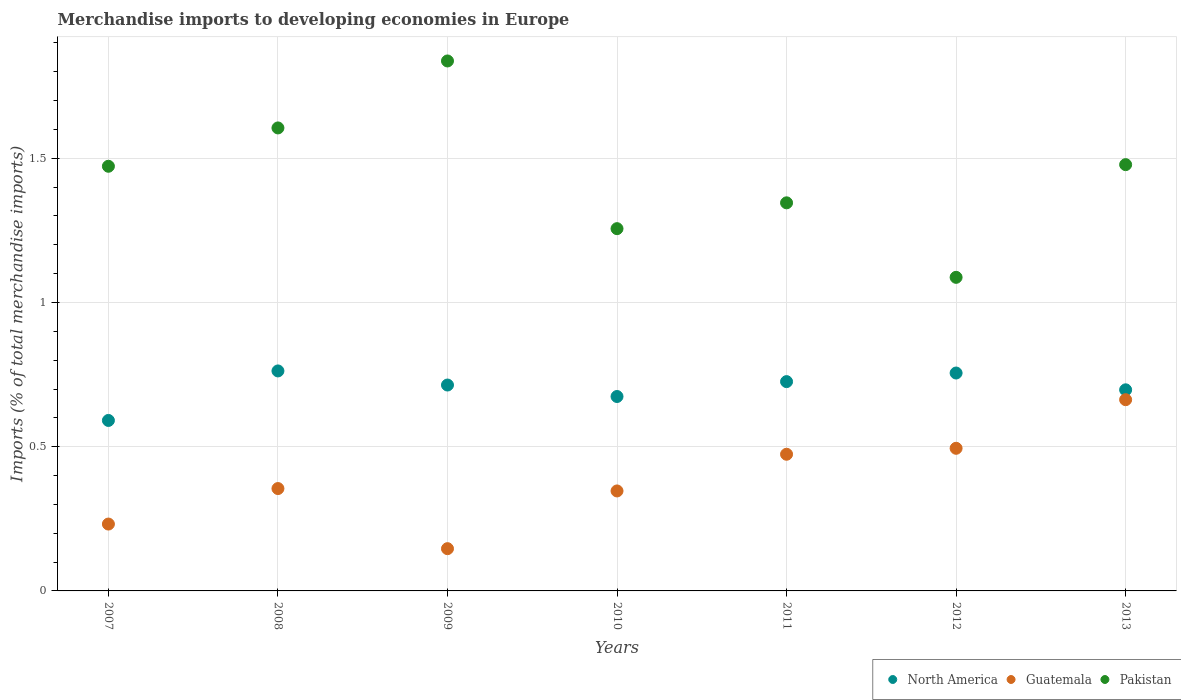How many different coloured dotlines are there?
Make the answer very short. 3. What is the percentage total merchandise imports in North America in 2007?
Your answer should be very brief. 0.59. Across all years, what is the maximum percentage total merchandise imports in North America?
Your answer should be very brief. 0.76. Across all years, what is the minimum percentage total merchandise imports in Guatemala?
Offer a very short reply. 0.15. What is the total percentage total merchandise imports in North America in the graph?
Your answer should be very brief. 4.92. What is the difference between the percentage total merchandise imports in North America in 2007 and that in 2008?
Ensure brevity in your answer.  -0.17. What is the difference between the percentage total merchandise imports in Guatemala in 2010 and the percentage total merchandise imports in Pakistan in 2008?
Keep it short and to the point. -1.26. What is the average percentage total merchandise imports in Guatemala per year?
Keep it short and to the point. 0.39. In the year 2012, what is the difference between the percentage total merchandise imports in Guatemala and percentage total merchandise imports in North America?
Your response must be concise. -0.26. In how many years, is the percentage total merchandise imports in North America greater than 0.30000000000000004 %?
Keep it short and to the point. 7. What is the ratio of the percentage total merchandise imports in Guatemala in 2008 to that in 2012?
Keep it short and to the point. 0.72. Is the difference between the percentage total merchandise imports in Guatemala in 2009 and 2013 greater than the difference between the percentage total merchandise imports in North America in 2009 and 2013?
Your answer should be compact. No. What is the difference between the highest and the second highest percentage total merchandise imports in Pakistan?
Provide a short and direct response. 0.23. What is the difference between the highest and the lowest percentage total merchandise imports in North America?
Offer a terse response. 0.17. In how many years, is the percentage total merchandise imports in North America greater than the average percentage total merchandise imports in North America taken over all years?
Make the answer very short. 4. Is the percentage total merchandise imports in Pakistan strictly less than the percentage total merchandise imports in Guatemala over the years?
Provide a succinct answer. No. Does the graph contain any zero values?
Your answer should be very brief. No. How many legend labels are there?
Keep it short and to the point. 3. What is the title of the graph?
Offer a very short reply. Merchandise imports to developing economies in Europe. What is the label or title of the Y-axis?
Offer a very short reply. Imports (% of total merchandise imports). What is the Imports (% of total merchandise imports) in North America in 2007?
Make the answer very short. 0.59. What is the Imports (% of total merchandise imports) of Guatemala in 2007?
Ensure brevity in your answer.  0.23. What is the Imports (% of total merchandise imports) of Pakistan in 2007?
Offer a terse response. 1.47. What is the Imports (% of total merchandise imports) of North America in 2008?
Offer a terse response. 0.76. What is the Imports (% of total merchandise imports) of Guatemala in 2008?
Provide a short and direct response. 0.35. What is the Imports (% of total merchandise imports) in Pakistan in 2008?
Offer a terse response. 1.61. What is the Imports (% of total merchandise imports) of North America in 2009?
Provide a succinct answer. 0.71. What is the Imports (% of total merchandise imports) in Guatemala in 2009?
Your answer should be very brief. 0.15. What is the Imports (% of total merchandise imports) of Pakistan in 2009?
Offer a very short reply. 1.84. What is the Imports (% of total merchandise imports) in North America in 2010?
Provide a short and direct response. 0.67. What is the Imports (% of total merchandise imports) of Guatemala in 2010?
Your answer should be very brief. 0.35. What is the Imports (% of total merchandise imports) of Pakistan in 2010?
Make the answer very short. 1.26. What is the Imports (% of total merchandise imports) of North America in 2011?
Your answer should be compact. 0.73. What is the Imports (% of total merchandise imports) of Guatemala in 2011?
Give a very brief answer. 0.47. What is the Imports (% of total merchandise imports) in Pakistan in 2011?
Make the answer very short. 1.35. What is the Imports (% of total merchandise imports) of North America in 2012?
Keep it short and to the point. 0.76. What is the Imports (% of total merchandise imports) of Guatemala in 2012?
Offer a very short reply. 0.49. What is the Imports (% of total merchandise imports) in Pakistan in 2012?
Your response must be concise. 1.09. What is the Imports (% of total merchandise imports) of North America in 2013?
Offer a very short reply. 0.7. What is the Imports (% of total merchandise imports) of Guatemala in 2013?
Your response must be concise. 0.66. What is the Imports (% of total merchandise imports) in Pakistan in 2013?
Ensure brevity in your answer.  1.48. Across all years, what is the maximum Imports (% of total merchandise imports) in North America?
Ensure brevity in your answer.  0.76. Across all years, what is the maximum Imports (% of total merchandise imports) of Guatemala?
Your answer should be compact. 0.66. Across all years, what is the maximum Imports (% of total merchandise imports) of Pakistan?
Offer a terse response. 1.84. Across all years, what is the minimum Imports (% of total merchandise imports) in North America?
Provide a short and direct response. 0.59. Across all years, what is the minimum Imports (% of total merchandise imports) in Guatemala?
Make the answer very short. 0.15. Across all years, what is the minimum Imports (% of total merchandise imports) of Pakistan?
Give a very brief answer. 1.09. What is the total Imports (% of total merchandise imports) of North America in the graph?
Offer a terse response. 4.92. What is the total Imports (% of total merchandise imports) of Guatemala in the graph?
Offer a very short reply. 2.71. What is the total Imports (% of total merchandise imports) in Pakistan in the graph?
Offer a terse response. 10.08. What is the difference between the Imports (% of total merchandise imports) in North America in 2007 and that in 2008?
Ensure brevity in your answer.  -0.17. What is the difference between the Imports (% of total merchandise imports) in Guatemala in 2007 and that in 2008?
Make the answer very short. -0.12. What is the difference between the Imports (% of total merchandise imports) in Pakistan in 2007 and that in 2008?
Make the answer very short. -0.13. What is the difference between the Imports (% of total merchandise imports) in North America in 2007 and that in 2009?
Your answer should be very brief. -0.12. What is the difference between the Imports (% of total merchandise imports) of Guatemala in 2007 and that in 2009?
Ensure brevity in your answer.  0.09. What is the difference between the Imports (% of total merchandise imports) of Pakistan in 2007 and that in 2009?
Provide a succinct answer. -0.37. What is the difference between the Imports (% of total merchandise imports) of North America in 2007 and that in 2010?
Provide a short and direct response. -0.08. What is the difference between the Imports (% of total merchandise imports) of Guatemala in 2007 and that in 2010?
Provide a short and direct response. -0.11. What is the difference between the Imports (% of total merchandise imports) of Pakistan in 2007 and that in 2010?
Your response must be concise. 0.22. What is the difference between the Imports (% of total merchandise imports) of North America in 2007 and that in 2011?
Offer a very short reply. -0.13. What is the difference between the Imports (% of total merchandise imports) in Guatemala in 2007 and that in 2011?
Keep it short and to the point. -0.24. What is the difference between the Imports (% of total merchandise imports) in Pakistan in 2007 and that in 2011?
Your answer should be compact. 0.13. What is the difference between the Imports (% of total merchandise imports) of North America in 2007 and that in 2012?
Give a very brief answer. -0.16. What is the difference between the Imports (% of total merchandise imports) of Guatemala in 2007 and that in 2012?
Offer a very short reply. -0.26. What is the difference between the Imports (% of total merchandise imports) in Pakistan in 2007 and that in 2012?
Ensure brevity in your answer.  0.39. What is the difference between the Imports (% of total merchandise imports) in North America in 2007 and that in 2013?
Provide a short and direct response. -0.11. What is the difference between the Imports (% of total merchandise imports) in Guatemala in 2007 and that in 2013?
Ensure brevity in your answer.  -0.43. What is the difference between the Imports (% of total merchandise imports) in Pakistan in 2007 and that in 2013?
Make the answer very short. -0.01. What is the difference between the Imports (% of total merchandise imports) in North America in 2008 and that in 2009?
Give a very brief answer. 0.05. What is the difference between the Imports (% of total merchandise imports) in Guatemala in 2008 and that in 2009?
Keep it short and to the point. 0.21. What is the difference between the Imports (% of total merchandise imports) in Pakistan in 2008 and that in 2009?
Your answer should be very brief. -0.23. What is the difference between the Imports (% of total merchandise imports) in North America in 2008 and that in 2010?
Your answer should be compact. 0.09. What is the difference between the Imports (% of total merchandise imports) of Guatemala in 2008 and that in 2010?
Offer a very short reply. 0.01. What is the difference between the Imports (% of total merchandise imports) of Pakistan in 2008 and that in 2010?
Your response must be concise. 0.35. What is the difference between the Imports (% of total merchandise imports) of North America in 2008 and that in 2011?
Your answer should be very brief. 0.04. What is the difference between the Imports (% of total merchandise imports) of Guatemala in 2008 and that in 2011?
Give a very brief answer. -0.12. What is the difference between the Imports (% of total merchandise imports) of Pakistan in 2008 and that in 2011?
Provide a short and direct response. 0.26. What is the difference between the Imports (% of total merchandise imports) in North America in 2008 and that in 2012?
Offer a very short reply. 0.01. What is the difference between the Imports (% of total merchandise imports) in Guatemala in 2008 and that in 2012?
Ensure brevity in your answer.  -0.14. What is the difference between the Imports (% of total merchandise imports) of Pakistan in 2008 and that in 2012?
Provide a succinct answer. 0.52. What is the difference between the Imports (% of total merchandise imports) in North America in 2008 and that in 2013?
Offer a terse response. 0.07. What is the difference between the Imports (% of total merchandise imports) of Guatemala in 2008 and that in 2013?
Make the answer very short. -0.31. What is the difference between the Imports (% of total merchandise imports) of Pakistan in 2008 and that in 2013?
Ensure brevity in your answer.  0.13. What is the difference between the Imports (% of total merchandise imports) of North America in 2009 and that in 2010?
Your answer should be very brief. 0.04. What is the difference between the Imports (% of total merchandise imports) in Guatemala in 2009 and that in 2010?
Your response must be concise. -0.2. What is the difference between the Imports (% of total merchandise imports) in Pakistan in 2009 and that in 2010?
Make the answer very short. 0.58. What is the difference between the Imports (% of total merchandise imports) in North America in 2009 and that in 2011?
Ensure brevity in your answer.  -0.01. What is the difference between the Imports (% of total merchandise imports) of Guatemala in 2009 and that in 2011?
Keep it short and to the point. -0.33. What is the difference between the Imports (% of total merchandise imports) in Pakistan in 2009 and that in 2011?
Keep it short and to the point. 0.49. What is the difference between the Imports (% of total merchandise imports) of North America in 2009 and that in 2012?
Give a very brief answer. -0.04. What is the difference between the Imports (% of total merchandise imports) in Guatemala in 2009 and that in 2012?
Your answer should be compact. -0.35. What is the difference between the Imports (% of total merchandise imports) of Pakistan in 2009 and that in 2012?
Your answer should be very brief. 0.75. What is the difference between the Imports (% of total merchandise imports) in North America in 2009 and that in 2013?
Provide a succinct answer. 0.02. What is the difference between the Imports (% of total merchandise imports) of Guatemala in 2009 and that in 2013?
Offer a terse response. -0.52. What is the difference between the Imports (% of total merchandise imports) in Pakistan in 2009 and that in 2013?
Your answer should be very brief. 0.36. What is the difference between the Imports (% of total merchandise imports) of North America in 2010 and that in 2011?
Your response must be concise. -0.05. What is the difference between the Imports (% of total merchandise imports) of Guatemala in 2010 and that in 2011?
Provide a short and direct response. -0.13. What is the difference between the Imports (% of total merchandise imports) of Pakistan in 2010 and that in 2011?
Your answer should be very brief. -0.09. What is the difference between the Imports (% of total merchandise imports) of North America in 2010 and that in 2012?
Make the answer very short. -0.08. What is the difference between the Imports (% of total merchandise imports) in Guatemala in 2010 and that in 2012?
Provide a short and direct response. -0.15. What is the difference between the Imports (% of total merchandise imports) of Pakistan in 2010 and that in 2012?
Offer a very short reply. 0.17. What is the difference between the Imports (% of total merchandise imports) in North America in 2010 and that in 2013?
Your answer should be compact. -0.02. What is the difference between the Imports (% of total merchandise imports) in Guatemala in 2010 and that in 2013?
Provide a short and direct response. -0.32. What is the difference between the Imports (% of total merchandise imports) of Pakistan in 2010 and that in 2013?
Provide a succinct answer. -0.22. What is the difference between the Imports (% of total merchandise imports) of North America in 2011 and that in 2012?
Your answer should be very brief. -0.03. What is the difference between the Imports (% of total merchandise imports) in Guatemala in 2011 and that in 2012?
Offer a very short reply. -0.02. What is the difference between the Imports (% of total merchandise imports) of Pakistan in 2011 and that in 2012?
Your answer should be very brief. 0.26. What is the difference between the Imports (% of total merchandise imports) in North America in 2011 and that in 2013?
Offer a terse response. 0.03. What is the difference between the Imports (% of total merchandise imports) of Guatemala in 2011 and that in 2013?
Your response must be concise. -0.19. What is the difference between the Imports (% of total merchandise imports) of Pakistan in 2011 and that in 2013?
Ensure brevity in your answer.  -0.13. What is the difference between the Imports (% of total merchandise imports) in North America in 2012 and that in 2013?
Offer a terse response. 0.06. What is the difference between the Imports (% of total merchandise imports) in Guatemala in 2012 and that in 2013?
Give a very brief answer. -0.17. What is the difference between the Imports (% of total merchandise imports) in Pakistan in 2012 and that in 2013?
Provide a short and direct response. -0.39. What is the difference between the Imports (% of total merchandise imports) in North America in 2007 and the Imports (% of total merchandise imports) in Guatemala in 2008?
Your answer should be very brief. 0.24. What is the difference between the Imports (% of total merchandise imports) in North America in 2007 and the Imports (% of total merchandise imports) in Pakistan in 2008?
Ensure brevity in your answer.  -1.01. What is the difference between the Imports (% of total merchandise imports) in Guatemala in 2007 and the Imports (% of total merchandise imports) in Pakistan in 2008?
Your response must be concise. -1.37. What is the difference between the Imports (% of total merchandise imports) in North America in 2007 and the Imports (% of total merchandise imports) in Guatemala in 2009?
Offer a terse response. 0.44. What is the difference between the Imports (% of total merchandise imports) in North America in 2007 and the Imports (% of total merchandise imports) in Pakistan in 2009?
Provide a succinct answer. -1.25. What is the difference between the Imports (% of total merchandise imports) in Guatemala in 2007 and the Imports (% of total merchandise imports) in Pakistan in 2009?
Your answer should be very brief. -1.61. What is the difference between the Imports (% of total merchandise imports) in North America in 2007 and the Imports (% of total merchandise imports) in Guatemala in 2010?
Your answer should be compact. 0.24. What is the difference between the Imports (% of total merchandise imports) in North America in 2007 and the Imports (% of total merchandise imports) in Pakistan in 2010?
Your response must be concise. -0.66. What is the difference between the Imports (% of total merchandise imports) in Guatemala in 2007 and the Imports (% of total merchandise imports) in Pakistan in 2010?
Your response must be concise. -1.02. What is the difference between the Imports (% of total merchandise imports) in North America in 2007 and the Imports (% of total merchandise imports) in Guatemala in 2011?
Your answer should be very brief. 0.12. What is the difference between the Imports (% of total merchandise imports) of North America in 2007 and the Imports (% of total merchandise imports) of Pakistan in 2011?
Make the answer very short. -0.75. What is the difference between the Imports (% of total merchandise imports) of Guatemala in 2007 and the Imports (% of total merchandise imports) of Pakistan in 2011?
Keep it short and to the point. -1.11. What is the difference between the Imports (% of total merchandise imports) of North America in 2007 and the Imports (% of total merchandise imports) of Guatemala in 2012?
Provide a succinct answer. 0.1. What is the difference between the Imports (% of total merchandise imports) in North America in 2007 and the Imports (% of total merchandise imports) in Pakistan in 2012?
Provide a short and direct response. -0.5. What is the difference between the Imports (% of total merchandise imports) in Guatemala in 2007 and the Imports (% of total merchandise imports) in Pakistan in 2012?
Your answer should be very brief. -0.86. What is the difference between the Imports (% of total merchandise imports) of North America in 2007 and the Imports (% of total merchandise imports) of Guatemala in 2013?
Offer a very short reply. -0.07. What is the difference between the Imports (% of total merchandise imports) of North America in 2007 and the Imports (% of total merchandise imports) of Pakistan in 2013?
Give a very brief answer. -0.89. What is the difference between the Imports (% of total merchandise imports) of Guatemala in 2007 and the Imports (% of total merchandise imports) of Pakistan in 2013?
Your answer should be very brief. -1.25. What is the difference between the Imports (% of total merchandise imports) in North America in 2008 and the Imports (% of total merchandise imports) in Guatemala in 2009?
Provide a succinct answer. 0.62. What is the difference between the Imports (% of total merchandise imports) of North America in 2008 and the Imports (% of total merchandise imports) of Pakistan in 2009?
Ensure brevity in your answer.  -1.07. What is the difference between the Imports (% of total merchandise imports) in Guatemala in 2008 and the Imports (% of total merchandise imports) in Pakistan in 2009?
Your answer should be very brief. -1.48. What is the difference between the Imports (% of total merchandise imports) in North America in 2008 and the Imports (% of total merchandise imports) in Guatemala in 2010?
Offer a very short reply. 0.42. What is the difference between the Imports (% of total merchandise imports) in North America in 2008 and the Imports (% of total merchandise imports) in Pakistan in 2010?
Ensure brevity in your answer.  -0.49. What is the difference between the Imports (% of total merchandise imports) in Guatemala in 2008 and the Imports (% of total merchandise imports) in Pakistan in 2010?
Your answer should be compact. -0.9. What is the difference between the Imports (% of total merchandise imports) in North America in 2008 and the Imports (% of total merchandise imports) in Guatemala in 2011?
Your response must be concise. 0.29. What is the difference between the Imports (% of total merchandise imports) of North America in 2008 and the Imports (% of total merchandise imports) of Pakistan in 2011?
Offer a very short reply. -0.58. What is the difference between the Imports (% of total merchandise imports) of Guatemala in 2008 and the Imports (% of total merchandise imports) of Pakistan in 2011?
Offer a very short reply. -0.99. What is the difference between the Imports (% of total merchandise imports) in North America in 2008 and the Imports (% of total merchandise imports) in Guatemala in 2012?
Provide a short and direct response. 0.27. What is the difference between the Imports (% of total merchandise imports) in North America in 2008 and the Imports (% of total merchandise imports) in Pakistan in 2012?
Provide a succinct answer. -0.32. What is the difference between the Imports (% of total merchandise imports) in Guatemala in 2008 and the Imports (% of total merchandise imports) in Pakistan in 2012?
Your response must be concise. -0.73. What is the difference between the Imports (% of total merchandise imports) in North America in 2008 and the Imports (% of total merchandise imports) in Guatemala in 2013?
Your answer should be compact. 0.1. What is the difference between the Imports (% of total merchandise imports) of North America in 2008 and the Imports (% of total merchandise imports) of Pakistan in 2013?
Give a very brief answer. -0.72. What is the difference between the Imports (% of total merchandise imports) in Guatemala in 2008 and the Imports (% of total merchandise imports) in Pakistan in 2013?
Provide a succinct answer. -1.12. What is the difference between the Imports (% of total merchandise imports) of North America in 2009 and the Imports (% of total merchandise imports) of Guatemala in 2010?
Offer a terse response. 0.37. What is the difference between the Imports (% of total merchandise imports) of North America in 2009 and the Imports (% of total merchandise imports) of Pakistan in 2010?
Ensure brevity in your answer.  -0.54. What is the difference between the Imports (% of total merchandise imports) of Guatemala in 2009 and the Imports (% of total merchandise imports) of Pakistan in 2010?
Your answer should be very brief. -1.11. What is the difference between the Imports (% of total merchandise imports) in North America in 2009 and the Imports (% of total merchandise imports) in Guatemala in 2011?
Offer a terse response. 0.24. What is the difference between the Imports (% of total merchandise imports) in North America in 2009 and the Imports (% of total merchandise imports) in Pakistan in 2011?
Provide a succinct answer. -0.63. What is the difference between the Imports (% of total merchandise imports) in Guatemala in 2009 and the Imports (% of total merchandise imports) in Pakistan in 2011?
Provide a succinct answer. -1.2. What is the difference between the Imports (% of total merchandise imports) in North America in 2009 and the Imports (% of total merchandise imports) in Guatemala in 2012?
Keep it short and to the point. 0.22. What is the difference between the Imports (% of total merchandise imports) in North America in 2009 and the Imports (% of total merchandise imports) in Pakistan in 2012?
Offer a terse response. -0.37. What is the difference between the Imports (% of total merchandise imports) of Guatemala in 2009 and the Imports (% of total merchandise imports) of Pakistan in 2012?
Offer a terse response. -0.94. What is the difference between the Imports (% of total merchandise imports) in North America in 2009 and the Imports (% of total merchandise imports) in Guatemala in 2013?
Ensure brevity in your answer.  0.05. What is the difference between the Imports (% of total merchandise imports) in North America in 2009 and the Imports (% of total merchandise imports) in Pakistan in 2013?
Offer a very short reply. -0.76. What is the difference between the Imports (% of total merchandise imports) of Guatemala in 2009 and the Imports (% of total merchandise imports) of Pakistan in 2013?
Keep it short and to the point. -1.33. What is the difference between the Imports (% of total merchandise imports) of North America in 2010 and the Imports (% of total merchandise imports) of Guatemala in 2011?
Your response must be concise. 0.2. What is the difference between the Imports (% of total merchandise imports) in North America in 2010 and the Imports (% of total merchandise imports) in Pakistan in 2011?
Offer a terse response. -0.67. What is the difference between the Imports (% of total merchandise imports) of Guatemala in 2010 and the Imports (% of total merchandise imports) of Pakistan in 2011?
Your answer should be very brief. -1. What is the difference between the Imports (% of total merchandise imports) of North America in 2010 and the Imports (% of total merchandise imports) of Guatemala in 2012?
Ensure brevity in your answer.  0.18. What is the difference between the Imports (% of total merchandise imports) of North America in 2010 and the Imports (% of total merchandise imports) of Pakistan in 2012?
Offer a terse response. -0.41. What is the difference between the Imports (% of total merchandise imports) in Guatemala in 2010 and the Imports (% of total merchandise imports) in Pakistan in 2012?
Ensure brevity in your answer.  -0.74. What is the difference between the Imports (% of total merchandise imports) in North America in 2010 and the Imports (% of total merchandise imports) in Guatemala in 2013?
Ensure brevity in your answer.  0.01. What is the difference between the Imports (% of total merchandise imports) in North America in 2010 and the Imports (% of total merchandise imports) in Pakistan in 2013?
Your answer should be very brief. -0.8. What is the difference between the Imports (% of total merchandise imports) in Guatemala in 2010 and the Imports (% of total merchandise imports) in Pakistan in 2013?
Make the answer very short. -1.13. What is the difference between the Imports (% of total merchandise imports) of North America in 2011 and the Imports (% of total merchandise imports) of Guatemala in 2012?
Your response must be concise. 0.23. What is the difference between the Imports (% of total merchandise imports) of North America in 2011 and the Imports (% of total merchandise imports) of Pakistan in 2012?
Offer a very short reply. -0.36. What is the difference between the Imports (% of total merchandise imports) of Guatemala in 2011 and the Imports (% of total merchandise imports) of Pakistan in 2012?
Make the answer very short. -0.61. What is the difference between the Imports (% of total merchandise imports) of North America in 2011 and the Imports (% of total merchandise imports) of Guatemala in 2013?
Your answer should be very brief. 0.06. What is the difference between the Imports (% of total merchandise imports) in North America in 2011 and the Imports (% of total merchandise imports) in Pakistan in 2013?
Offer a terse response. -0.75. What is the difference between the Imports (% of total merchandise imports) of Guatemala in 2011 and the Imports (% of total merchandise imports) of Pakistan in 2013?
Provide a succinct answer. -1. What is the difference between the Imports (% of total merchandise imports) in North America in 2012 and the Imports (% of total merchandise imports) in Guatemala in 2013?
Provide a succinct answer. 0.09. What is the difference between the Imports (% of total merchandise imports) in North America in 2012 and the Imports (% of total merchandise imports) in Pakistan in 2013?
Keep it short and to the point. -0.72. What is the difference between the Imports (% of total merchandise imports) of Guatemala in 2012 and the Imports (% of total merchandise imports) of Pakistan in 2013?
Provide a succinct answer. -0.98. What is the average Imports (% of total merchandise imports) in North America per year?
Keep it short and to the point. 0.7. What is the average Imports (% of total merchandise imports) in Guatemala per year?
Your response must be concise. 0.39. What is the average Imports (% of total merchandise imports) in Pakistan per year?
Your answer should be very brief. 1.44. In the year 2007, what is the difference between the Imports (% of total merchandise imports) of North America and Imports (% of total merchandise imports) of Guatemala?
Your response must be concise. 0.36. In the year 2007, what is the difference between the Imports (% of total merchandise imports) in North America and Imports (% of total merchandise imports) in Pakistan?
Offer a very short reply. -0.88. In the year 2007, what is the difference between the Imports (% of total merchandise imports) in Guatemala and Imports (% of total merchandise imports) in Pakistan?
Your answer should be compact. -1.24. In the year 2008, what is the difference between the Imports (% of total merchandise imports) of North America and Imports (% of total merchandise imports) of Guatemala?
Your response must be concise. 0.41. In the year 2008, what is the difference between the Imports (% of total merchandise imports) of North America and Imports (% of total merchandise imports) of Pakistan?
Offer a very short reply. -0.84. In the year 2008, what is the difference between the Imports (% of total merchandise imports) in Guatemala and Imports (% of total merchandise imports) in Pakistan?
Provide a succinct answer. -1.25. In the year 2009, what is the difference between the Imports (% of total merchandise imports) in North America and Imports (% of total merchandise imports) in Guatemala?
Offer a very short reply. 0.57. In the year 2009, what is the difference between the Imports (% of total merchandise imports) of North America and Imports (% of total merchandise imports) of Pakistan?
Ensure brevity in your answer.  -1.12. In the year 2009, what is the difference between the Imports (% of total merchandise imports) in Guatemala and Imports (% of total merchandise imports) in Pakistan?
Offer a very short reply. -1.69. In the year 2010, what is the difference between the Imports (% of total merchandise imports) of North America and Imports (% of total merchandise imports) of Guatemala?
Provide a short and direct response. 0.33. In the year 2010, what is the difference between the Imports (% of total merchandise imports) of North America and Imports (% of total merchandise imports) of Pakistan?
Your response must be concise. -0.58. In the year 2010, what is the difference between the Imports (% of total merchandise imports) in Guatemala and Imports (% of total merchandise imports) in Pakistan?
Ensure brevity in your answer.  -0.91. In the year 2011, what is the difference between the Imports (% of total merchandise imports) of North America and Imports (% of total merchandise imports) of Guatemala?
Give a very brief answer. 0.25. In the year 2011, what is the difference between the Imports (% of total merchandise imports) in North America and Imports (% of total merchandise imports) in Pakistan?
Make the answer very short. -0.62. In the year 2011, what is the difference between the Imports (% of total merchandise imports) of Guatemala and Imports (% of total merchandise imports) of Pakistan?
Give a very brief answer. -0.87. In the year 2012, what is the difference between the Imports (% of total merchandise imports) in North America and Imports (% of total merchandise imports) in Guatemala?
Offer a terse response. 0.26. In the year 2012, what is the difference between the Imports (% of total merchandise imports) of North America and Imports (% of total merchandise imports) of Pakistan?
Offer a terse response. -0.33. In the year 2012, what is the difference between the Imports (% of total merchandise imports) of Guatemala and Imports (% of total merchandise imports) of Pakistan?
Give a very brief answer. -0.59. In the year 2013, what is the difference between the Imports (% of total merchandise imports) in North America and Imports (% of total merchandise imports) in Guatemala?
Keep it short and to the point. 0.03. In the year 2013, what is the difference between the Imports (% of total merchandise imports) in North America and Imports (% of total merchandise imports) in Pakistan?
Your answer should be very brief. -0.78. In the year 2013, what is the difference between the Imports (% of total merchandise imports) of Guatemala and Imports (% of total merchandise imports) of Pakistan?
Your response must be concise. -0.81. What is the ratio of the Imports (% of total merchandise imports) of North America in 2007 to that in 2008?
Ensure brevity in your answer.  0.77. What is the ratio of the Imports (% of total merchandise imports) in Guatemala in 2007 to that in 2008?
Keep it short and to the point. 0.65. What is the ratio of the Imports (% of total merchandise imports) in Pakistan in 2007 to that in 2008?
Keep it short and to the point. 0.92. What is the ratio of the Imports (% of total merchandise imports) of North America in 2007 to that in 2009?
Give a very brief answer. 0.83. What is the ratio of the Imports (% of total merchandise imports) in Guatemala in 2007 to that in 2009?
Your answer should be compact. 1.58. What is the ratio of the Imports (% of total merchandise imports) of Pakistan in 2007 to that in 2009?
Offer a terse response. 0.8. What is the ratio of the Imports (% of total merchandise imports) of North America in 2007 to that in 2010?
Your response must be concise. 0.88. What is the ratio of the Imports (% of total merchandise imports) of Guatemala in 2007 to that in 2010?
Your answer should be very brief. 0.67. What is the ratio of the Imports (% of total merchandise imports) of Pakistan in 2007 to that in 2010?
Your answer should be compact. 1.17. What is the ratio of the Imports (% of total merchandise imports) in North America in 2007 to that in 2011?
Keep it short and to the point. 0.81. What is the ratio of the Imports (% of total merchandise imports) in Guatemala in 2007 to that in 2011?
Provide a short and direct response. 0.49. What is the ratio of the Imports (% of total merchandise imports) in Pakistan in 2007 to that in 2011?
Provide a succinct answer. 1.09. What is the ratio of the Imports (% of total merchandise imports) in North America in 2007 to that in 2012?
Give a very brief answer. 0.78. What is the ratio of the Imports (% of total merchandise imports) in Guatemala in 2007 to that in 2012?
Your response must be concise. 0.47. What is the ratio of the Imports (% of total merchandise imports) in Pakistan in 2007 to that in 2012?
Make the answer very short. 1.35. What is the ratio of the Imports (% of total merchandise imports) of North America in 2007 to that in 2013?
Provide a succinct answer. 0.85. What is the ratio of the Imports (% of total merchandise imports) in Guatemala in 2007 to that in 2013?
Make the answer very short. 0.35. What is the ratio of the Imports (% of total merchandise imports) of Pakistan in 2007 to that in 2013?
Make the answer very short. 1. What is the ratio of the Imports (% of total merchandise imports) of North America in 2008 to that in 2009?
Your answer should be compact. 1.07. What is the ratio of the Imports (% of total merchandise imports) of Guatemala in 2008 to that in 2009?
Provide a short and direct response. 2.42. What is the ratio of the Imports (% of total merchandise imports) in Pakistan in 2008 to that in 2009?
Your answer should be compact. 0.87. What is the ratio of the Imports (% of total merchandise imports) in North America in 2008 to that in 2010?
Keep it short and to the point. 1.13. What is the ratio of the Imports (% of total merchandise imports) of Guatemala in 2008 to that in 2010?
Offer a very short reply. 1.02. What is the ratio of the Imports (% of total merchandise imports) of Pakistan in 2008 to that in 2010?
Your answer should be very brief. 1.28. What is the ratio of the Imports (% of total merchandise imports) of North America in 2008 to that in 2011?
Your response must be concise. 1.05. What is the ratio of the Imports (% of total merchandise imports) in Guatemala in 2008 to that in 2011?
Keep it short and to the point. 0.75. What is the ratio of the Imports (% of total merchandise imports) of Pakistan in 2008 to that in 2011?
Offer a terse response. 1.19. What is the ratio of the Imports (% of total merchandise imports) of North America in 2008 to that in 2012?
Ensure brevity in your answer.  1.01. What is the ratio of the Imports (% of total merchandise imports) of Guatemala in 2008 to that in 2012?
Provide a succinct answer. 0.72. What is the ratio of the Imports (% of total merchandise imports) in Pakistan in 2008 to that in 2012?
Give a very brief answer. 1.48. What is the ratio of the Imports (% of total merchandise imports) in North America in 2008 to that in 2013?
Offer a terse response. 1.09. What is the ratio of the Imports (% of total merchandise imports) of Guatemala in 2008 to that in 2013?
Give a very brief answer. 0.54. What is the ratio of the Imports (% of total merchandise imports) in Pakistan in 2008 to that in 2013?
Provide a succinct answer. 1.09. What is the ratio of the Imports (% of total merchandise imports) of North America in 2009 to that in 2010?
Your response must be concise. 1.06. What is the ratio of the Imports (% of total merchandise imports) of Guatemala in 2009 to that in 2010?
Ensure brevity in your answer.  0.42. What is the ratio of the Imports (% of total merchandise imports) in Pakistan in 2009 to that in 2010?
Your answer should be compact. 1.46. What is the ratio of the Imports (% of total merchandise imports) in North America in 2009 to that in 2011?
Your answer should be compact. 0.98. What is the ratio of the Imports (% of total merchandise imports) in Guatemala in 2009 to that in 2011?
Keep it short and to the point. 0.31. What is the ratio of the Imports (% of total merchandise imports) of Pakistan in 2009 to that in 2011?
Your answer should be very brief. 1.37. What is the ratio of the Imports (% of total merchandise imports) of North America in 2009 to that in 2012?
Make the answer very short. 0.94. What is the ratio of the Imports (% of total merchandise imports) of Guatemala in 2009 to that in 2012?
Offer a terse response. 0.3. What is the ratio of the Imports (% of total merchandise imports) of Pakistan in 2009 to that in 2012?
Offer a very short reply. 1.69. What is the ratio of the Imports (% of total merchandise imports) in North America in 2009 to that in 2013?
Make the answer very short. 1.02. What is the ratio of the Imports (% of total merchandise imports) of Guatemala in 2009 to that in 2013?
Offer a very short reply. 0.22. What is the ratio of the Imports (% of total merchandise imports) in Pakistan in 2009 to that in 2013?
Provide a succinct answer. 1.24. What is the ratio of the Imports (% of total merchandise imports) of North America in 2010 to that in 2011?
Your response must be concise. 0.93. What is the ratio of the Imports (% of total merchandise imports) of Guatemala in 2010 to that in 2011?
Provide a short and direct response. 0.73. What is the ratio of the Imports (% of total merchandise imports) in Pakistan in 2010 to that in 2011?
Provide a short and direct response. 0.93. What is the ratio of the Imports (% of total merchandise imports) of North America in 2010 to that in 2012?
Your answer should be compact. 0.89. What is the ratio of the Imports (% of total merchandise imports) in Guatemala in 2010 to that in 2012?
Your answer should be very brief. 0.7. What is the ratio of the Imports (% of total merchandise imports) of Pakistan in 2010 to that in 2012?
Provide a short and direct response. 1.16. What is the ratio of the Imports (% of total merchandise imports) of North America in 2010 to that in 2013?
Keep it short and to the point. 0.97. What is the ratio of the Imports (% of total merchandise imports) in Guatemala in 2010 to that in 2013?
Give a very brief answer. 0.52. What is the ratio of the Imports (% of total merchandise imports) of Pakistan in 2010 to that in 2013?
Your answer should be compact. 0.85. What is the ratio of the Imports (% of total merchandise imports) of North America in 2011 to that in 2012?
Provide a short and direct response. 0.96. What is the ratio of the Imports (% of total merchandise imports) of Guatemala in 2011 to that in 2012?
Provide a short and direct response. 0.96. What is the ratio of the Imports (% of total merchandise imports) in Pakistan in 2011 to that in 2012?
Give a very brief answer. 1.24. What is the ratio of the Imports (% of total merchandise imports) in North America in 2011 to that in 2013?
Offer a very short reply. 1.04. What is the ratio of the Imports (% of total merchandise imports) of Guatemala in 2011 to that in 2013?
Make the answer very short. 0.71. What is the ratio of the Imports (% of total merchandise imports) in Pakistan in 2011 to that in 2013?
Your response must be concise. 0.91. What is the ratio of the Imports (% of total merchandise imports) of North America in 2012 to that in 2013?
Keep it short and to the point. 1.08. What is the ratio of the Imports (% of total merchandise imports) in Guatemala in 2012 to that in 2013?
Offer a terse response. 0.75. What is the ratio of the Imports (% of total merchandise imports) in Pakistan in 2012 to that in 2013?
Give a very brief answer. 0.74. What is the difference between the highest and the second highest Imports (% of total merchandise imports) in North America?
Your response must be concise. 0.01. What is the difference between the highest and the second highest Imports (% of total merchandise imports) in Guatemala?
Offer a very short reply. 0.17. What is the difference between the highest and the second highest Imports (% of total merchandise imports) of Pakistan?
Your answer should be compact. 0.23. What is the difference between the highest and the lowest Imports (% of total merchandise imports) in North America?
Your answer should be compact. 0.17. What is the difference between the highest and the lowest Imports (% of total merchandise imports) of Guatemala?
Your answer should be very brief. 0.52. What is the difference between the highest and the lowest Imports (% of total merchandise imports) of Pakistan?
Make the answer very short. 0.75. 